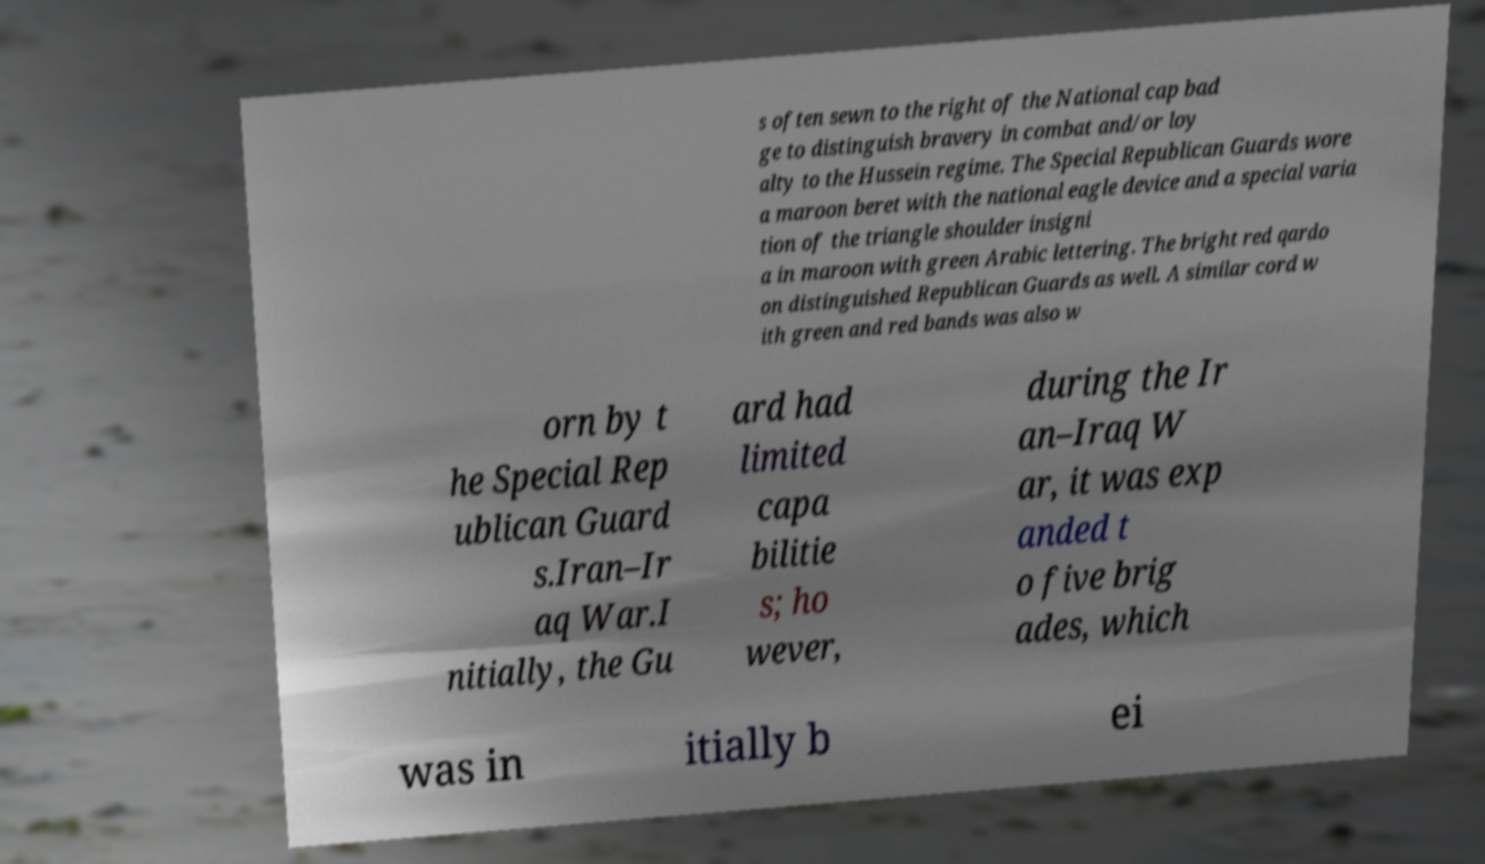For documentation purposes, I need the text within this image transcribed. Could you provide that? s often sewn to the right of the National cap bad ge to distinguish bravery in combat and/or loy alty to the Hussein regime. The Special Republican Guards wore a maroon beret with the national eagle device and a special varia tion of the triangle shoulder insigni a in maroon with green Arabic lettering. The bright red qardo on distinguished Republican Guards as well. A similar cord w ith green and red bands was also w orn by t he Special Rep ublican Guard s.Iran–Ir aq War.I nitially, the Gu ard had limited capa bilitie s; ho wever, during the Ir an–Iraq W ar, it was exp anded t o five brig ades, which was in itially b ei 